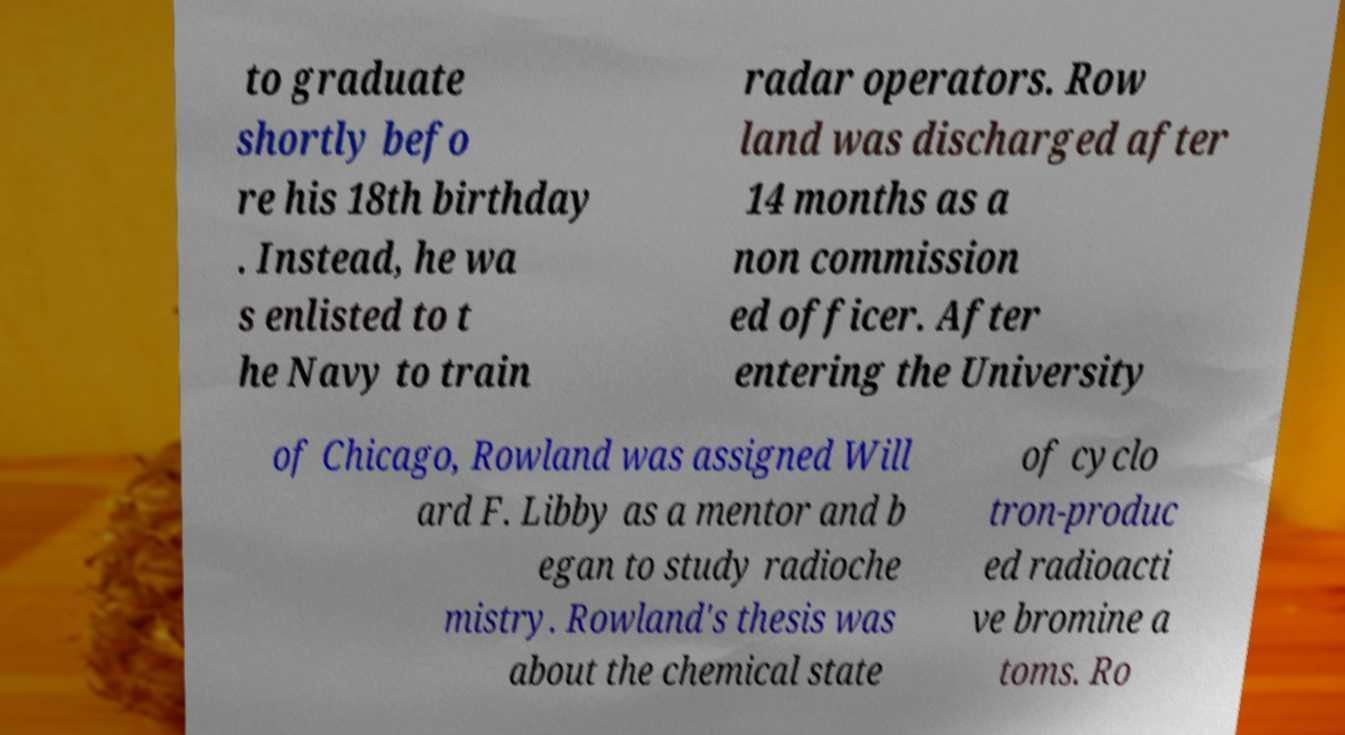Please identify and transcribe the text found in this image. to graduate shortly befo re his 18th birthday . Instead, he wa s enlisted to t he Navy to train radar operators. Row land was discharged after 14 months as a non commission ed officer. After entering the University of Chicago, Rowland was assigned Will ard F. Libby as a mentor and b egan to study radioche mistry. Rowland's thesis was about the chemical state of cyclo tron-produc ed radioacti ve bromine a toms. Ro 